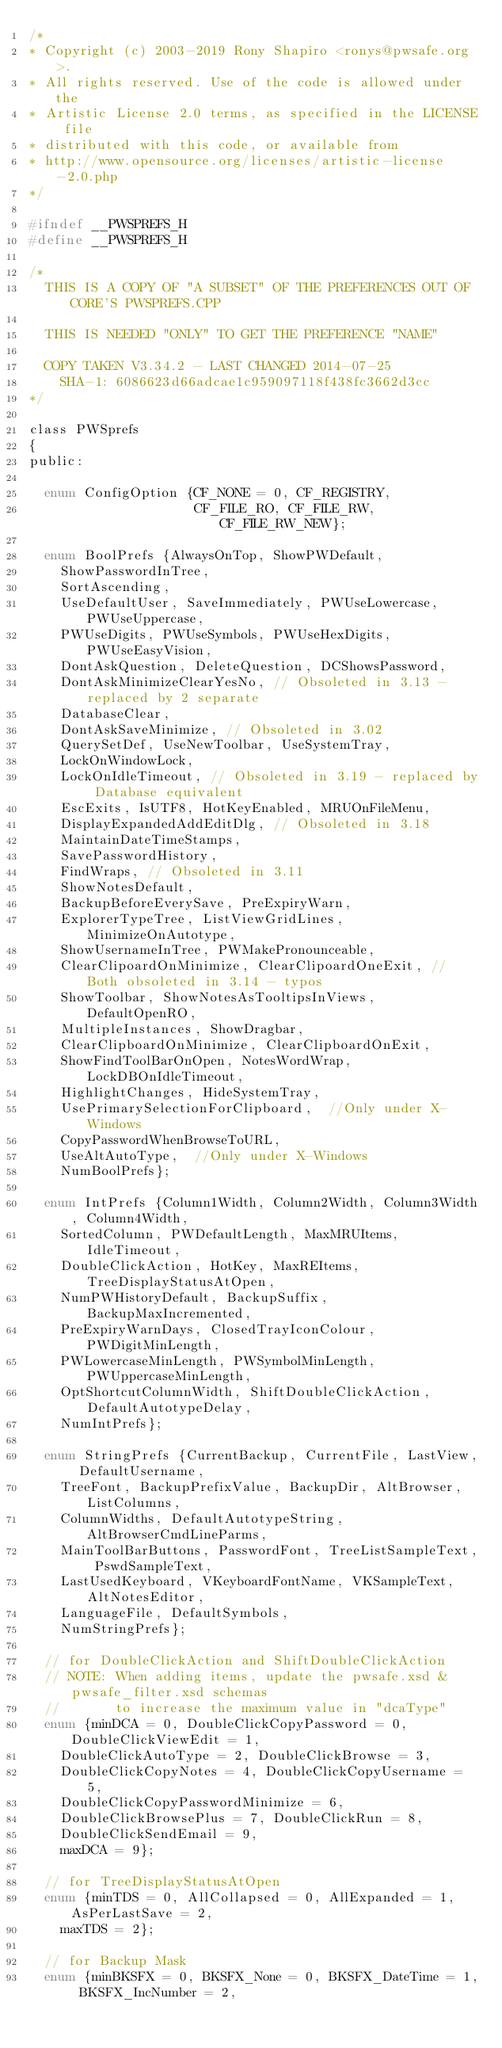Convert code to text. <code><loc_0><loc_0><loc_500><loc_500><_C_>/*
* Copyright (c) 2003-2019 Rony Shapiro <ronys@pwsafe.org>.
* All rights reserved. Use of the code is allowed under the
* Artistic License 2.0 terms, as specified in the LICENSE file
* distributed with this code, or available from
* http://www.opensource.org/licenses/artistic-license-2.0.php
*/

#ifndef __PWSPREFS_H
#define __PWSPREFS_H

/*
  THIS IS A COPY OF "A SUBSET" OF THE PREFERENCES OUT OF CORE'S PWSPREFS.CPP

  THIS IS NEEDED "ONLY" TO GET THE PREFERENCE "NAME"

  COPY TAKEN V3.34.2 - LAST CHANGED 2014-07-25
    SHA-1: 6086623d66adcae1c959097118f438fc3662d3cc
*/

class PWSprefs
{
public:

  enum ConfigOption {CF_NONE = 0, CF_REGISTRY,
                     CF_FILE_RO, CF_FILE_RW, CF_FILE_RW_NEW};

  enum BoolPrefs {AlwaysOnTop, ShowPWDefault,
    ShowPasswordInTree,
    SortAscending,
    UseDefaultUser, SaveImmediately, PWUseLowercase, PWUseUppercase,
    PWUseDigits, PWUseSymbols, PWUseHexDigits, PWUseEasyVision,
    DontAskQuestion, DeleteQuestion, DCShowsPassword,
    DontAskMinimizeClearYesNo, // Obsoleted in 3.13 - replaced by 2 separate
    DatabaseClear,
    DontAskSaveMinimize, // Obsoleted in 3.02
    QuerySetDef, UseNewToolbar, UseSystemTray,
    LockOnWindowLock,
    LockOnIdleTimeout, // Obsoleted in 3.19 - replaced by Database equivalent
    EscExits, IsUTF8, HotKeyEnabled, MRUOnFileMenu,
    DisplayExpandedAddEditDlg, // Obsoleted in 3.18
    MaintainDateTimeStamps,
    SavePasswordHistory,
    FindWraps, // Obsoleted in 3.11
    ShowNotesDefault,
    BackupBeforeEverySave, PreExpiryWarn,
    ExplorerTypeTree, ListViewGridLines, MinimizeOnAutotype,
    ShowUsernameInTree, PWMakePronounceable,
    ClearClipoardOnMinimize, ClearClipoardOneExit, // Both obsoleted in 3.14 - typos
    ShowToolbar, ShowNotesAsTooltipsInViews, DefaultOpenRO,
    MultipleInstances, ShowDragbar,
    ClearClipboardOnMinimize, ClearClipboardOnExit,
    ShowFindToolBarOnOpen, NotesWordWrap, LockDBOnIdleTimeout,
    HighlightChanges, HideSystemTray,
    UsePrimarySelectionForClipboard,  //Only under X-Windows
    CopyPasswordWhenBrowseToURL,
    UseAltAutoType,  //Only under X-Windows
    NumBoolPrefs};

  enum IntPrefs {Column1Width, Column2Width, Column3Width, Column4Width,
    SortedColumn, PWDefaultLength, MaxMRUItems, IdleTimeout,
    DoubleClickAction, HotKey, MaxREItems, TreeDisplayStatusAtOpen,
    NumPWHistoryDefault, BackupSuffix, BackupMaxIncremented,
    PreExpiryWarnDays, ClosedTrayIconColour, PWDigitMinLength,
    PWLowercaseMinLength, PWSymbolMinLength, PWUppercaseMinLength,
    OptShortcutColumnWidth, ShiftDoubleClickAction, DefaultAutotypeDelay,
    NumIntPrefs};

  enum StringPrefs {CurrentBackup, CurrentFile, LastView, DefaultUsername,
    TreeFont, BackupPrefixValue, BackupDir, AltBrowser, ListColumns,
    ColumnWidths, DefaultAutotypeString, AltBrowserCmdLineParms,
    MainToolBarButtons, PasswordFont, TreeListSampleText, PswdSampleText,
    LastUsedKeyboard, VKeyboardFontName, VKSampleText, AltNotesEditor,
    LanguageFile, DefaultSymbols,
    NumStringPrefs};

  // for DoubleClickAction and ShiftDoubleClickAction
  // NOTE: When adding items, update the pwsafe.xsd & pwsafe_filter.xsd schemas
  //       to increase the maximum value in "dcaType"
  enum {minDCA = 0, DoubleClickCopyPassword = 0, DoubleClickViewEdit = 1,
    DoubleClickAutoType = 2, DoubleClickBrowse = 3,
    DoubleClickCopyNotes = 4, DoubleClickCopyUsername = 5,
    DoubleClickCopyPasswordMinimize = 6,
    DoubleClickBrowsePlus = 7, DoubleClickRun = 8,
    DoubleClickSendEmail = 9,
    maxDCA = 9};

  // for TreeDisplayStatusAtOpen
  enum {minTDS = 0, AllCollapsed = 0, AllExpanded = 1, AsPerLastSave = 2,
    maxTDS = 2};

  // for Backup Mask
  enum {minBKSFX = 0, BKSFX_None = 0, BKSFX_DateTime = 1, BKSFX_IncNumber = 2,</code> 